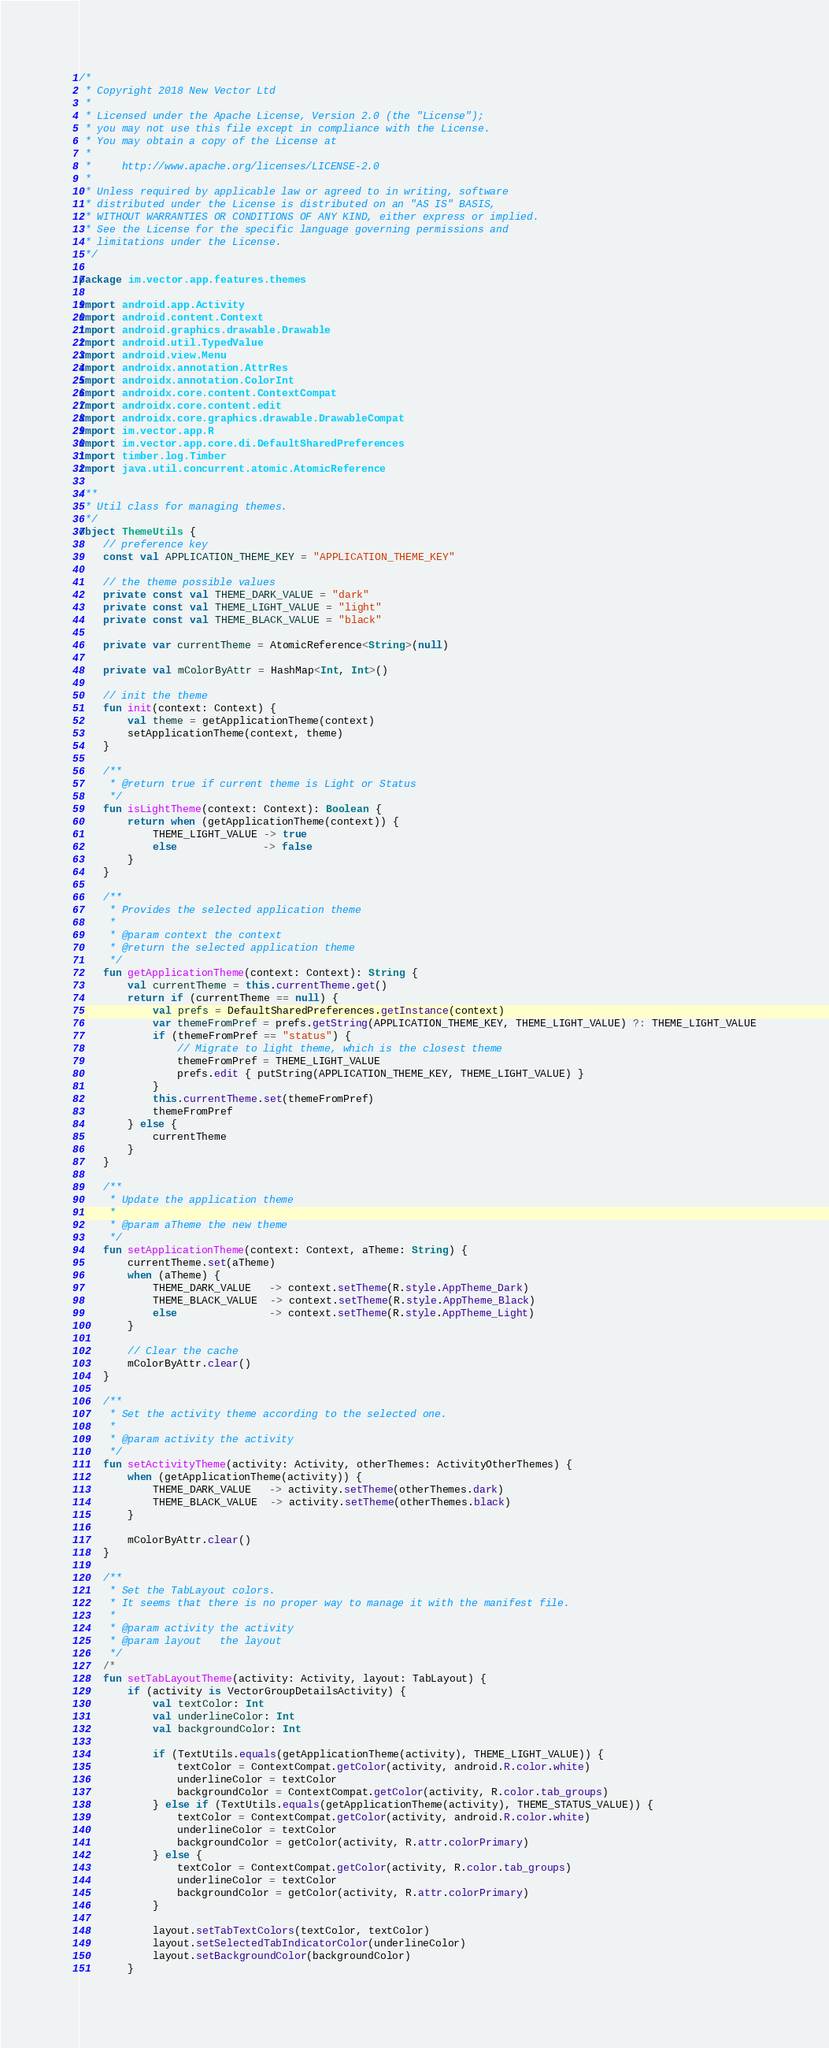Convert code to text. <code><loc_0><loc_0><loc_500><loc_500><_Kotlin_>/*
 * Copyright 2018 New Vector Ltd
 *
 * Licensed under the Apache License, Version 2.0 (the "License");
 * you may not use this file except in compliance with the License.
 * You may obtain a copy of the License at
 *
 *     http://www.apache.org/licenses/LICENSE-2.0
 *
 * Unless required by applicable law or agreed to in writing, software
 * distributed under the License is distributed on an "AS IS" BASIS,
 * WITHOUT WARRANTIES OR CONDITIONS OF ANY KIND, either express or implied.
 * See the License for the specific language governing permissions and
 * limitations under the License.
 */

package im.vector.app.features.themes

import android.app.Activity
import android.content.Context
import android.graphics.drawable.Drawable
import android.util.TypedValue
import android.view.Menu
import androidx.annotation.AttrRes
import androidx.annotation.ColorInt
import androidx.core.content.ContextCompat
import androidx.core.content.edit
import androidx.core.graphics.drawable.DrawableCompat
import im.vector.app.R
import im.vector.app.core.di.DefaultSharedPreferences
import timber.log.Timber
import java.util.concurrent.atomic.AtomicReference

/**
 * Util class for managing themes.
 */
object ThemeUtils {
    // preference key
    const val APPLICATION_THEME_KEY = "APPLICATION_THEME_KEY"

    // the theme possible values
    private const val THEME_DARK_VALUE = "dark"
    private const val THEME_LIGHT_VALUE = "light"
    private const val THEME_BLACK_VALUE = "black"

    private var currentTheme = AtomicReference<String>(null)

    private val mColorByAttr = HashMap<Int, Int>()

    // init the theme
    fun init(context: Context) {
        val theme = getApplicationTheme(context)
        setApplicationTheme(context, theme)
    }

    /**
     * @return true if current theme is Light or Status
     */
    fun isLightTheme(context: Context): Boolean {
        return when (getApplicationTheme(context)) {
            THEME_LIGHT_VALUE -> true
            else              -> false
        }
    }

    /**
     * Provides the selected application theme
     *
     * @param context the context
     * @return the selected application theme
     */
    fun getApplicationTheme(context: Context): String {
        val currentTheme = this.currentTheme.get()
        return if (currentTheme == null) {
            val prefs = DefaultSharedPreferences.getInstance(context)
            var themeFromPref = prefs.getString(APPLICATION_THEME_KEY, THEME_LIGHT_VALUE) ?: THEME_LIGHT_VALUE
            if (themeFromPref == "status") {
                // Migrate to light theme, which is the closest theme
                themeFromPref = THEME_LIGHT_VALUE
                prefs.edit { putString(APPLICATION_THEME_KEY, THEME_LIGHT_VALUE) }
            }
            this.currentTheme.set(themeFromPref)
            themeFromPref
        } else {
            currentTheme
        }
    }

    /**
     * Update the application theme
     *
     * @param aTheme the new theme
     */
    fun setApplicationTheme(context: Context, aTheme: String) {
        currentTheme.set(aTheme)
        when (aTheme) {
            THEME_DARK_VALUE   -> context.setTheme(R.style.AppTheme_Dark)
            THEME_BLACK_VALUE  -> context.setTheme(R.style.AppTheme_Black)
            else               -> context.setTheme(R.style.AppTheme_Light)
        }

        // Clear the cache
        mColorByAttr.clear()
    }

    /**
     * Set the activity theme according to the selected one.
     *
     * @param activity the activity
     */
    fun setActivityTheme(activity: Activity, otherThemes: ActivityOtherThemes) {
        when (getApplicationTheme(activity)) {
            THEME_DARK_VALUE   -> activity.setTheme(otherThemes.dark)
            THEME_BLACK_VALUE  -> activity.setTheme(otherThemes.black)
        }

        mColorByAttr.clear()
    }

    /**
     * Set the TabLayout colors.
     * It seems that there is no proper way to manage it with the manifest file.
     *
     * @param activity the activity
     * @param layout   the layout
     */
    /*
    fun setTabLayoutTheme(activity: Activity, layout: TabLayout) {
        if (activity is VectorGroupDetailsActivity) {
            val textColor: Int
            val underlineColor: Int
            val backgroundColor: Int

            if (TextUtils.equals(getApplicationTheme(activity), THEME_LIGHT_VALUE)) {
                textColor = ContextCompat.getColor(activity, android.R.color.white)
                underlineColor = textColor
                backgroundColor = ContextCompat.getColor(activity, R.color.tab_groups)
            } else if (TextUtils.equals(getApplicationTheme(activity), THEME_STATUS_VALUE)) {
                textColor = ContextCompat.getColor(activity, android.R.color.white)
                underlineColor = textColor
                backgroundColor = getColor(activity, R.attr.colorPrimary)
            } else {
                textColor = ContextCompat.getColor(activity, R.color.tab_groups)
                underlineColor = textColor
                backgroundColor = getColor(activity, R.attr.colorPrimary)
            }

            layout.setTabTextColors(textColor, textColor)
            layout.setSelectedTabIndicatorColor(underlineColor)
            layout.setBackgroundColor(backgroundColor)
        }</code> 